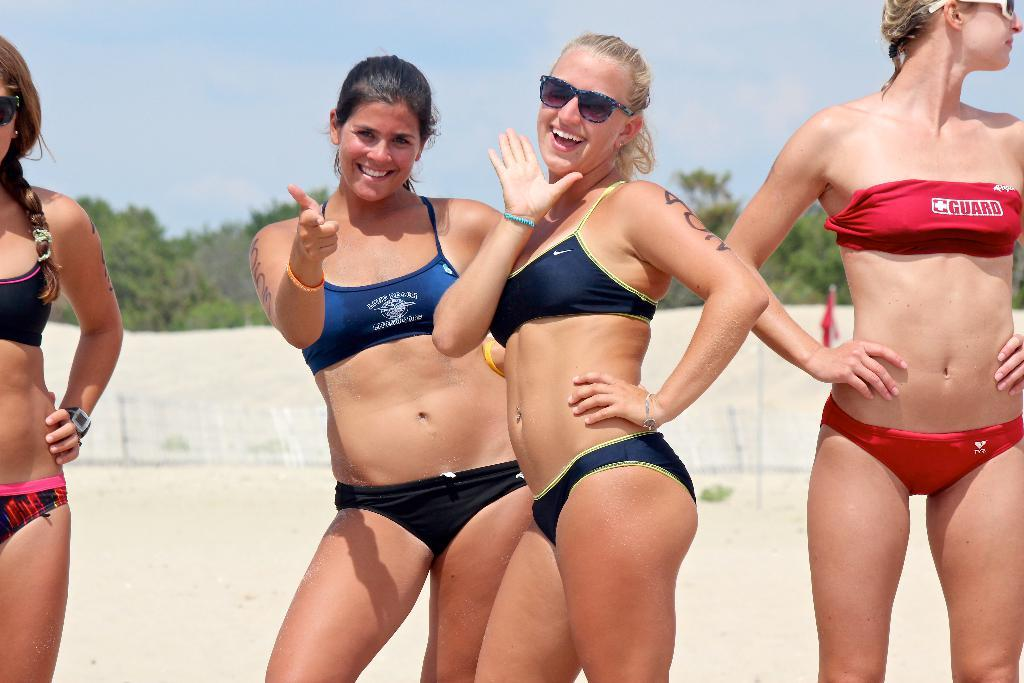How many people are present in the image? There are four women standing in the image. What can be seen in the background of the image? There are trees and the sky visible in the background of the image. What type of wheel is being used by the women in the image? There is no wheel present in the image; the women are standing without any visible wheel. 